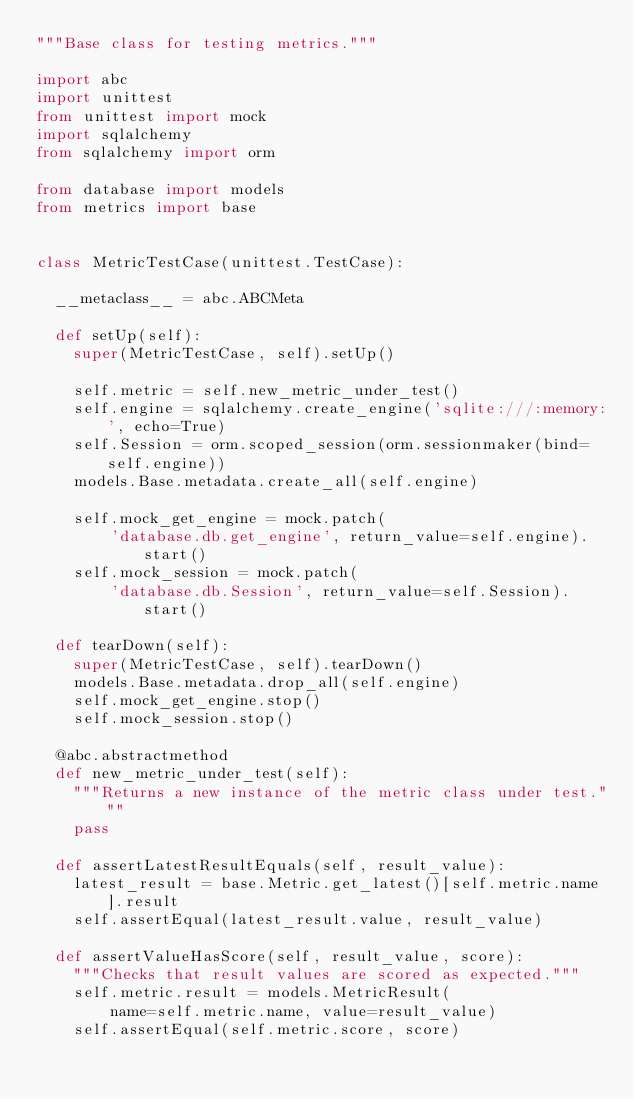Convert code to text. <code><loc_0><loc_0><loc_500><loc_500><_Python_>"""Base class for testing metrics."""

import abc
import unittest
from unittest import mock
import sqlalchemy
from sqlalchemy import orm

from database import models
from metrics import base


class MetricTestCase(unittest.TestCase):

  __metaclass__ = abc.ABCMeta

  def setUp(self):
    super(MetricTestCase, self).setUp()

    self.metric = self.new_metric_under_test()
    self.engine = sqlalchemy.create_engine('sqlite:///:memory:', echo=True)
    self.Session = orm.scoped_session(orm.sessionmaker(bind=self.engine))
    models.Base.metadata.create_all(self.engine)

    self.mock_get_engine = mock.patch(
        'database.db.get_engine', return_value=self.engine).start()
    self.mock_session = mock.patch(
        'database.db.Session', return_value=self.Session).start()

  def tearDown(self):
    super(MetricTestCase, self).tearDown()
    models.Base.metadata.drop_all(self.engine)
    self.mock_get_engine.stop()
    self.mock_session.stop()

  @abc.abstractmethod
  def new_metric_under_test(self):
    """Returns a new instance of the metric class under test."""
    pass

  def assertLatestResultEquals(self, result_value):
    latest_result = base.Metric.get_latest()[self.metric.name].result
    self.assertEqual(latest_result.value, result_value)

  def assertValueHasScore(self, result_value, score):
    """Checks that result values are scored as expected."""
    self.metric.result = models.MetricResult(
        name=self.metric.name, value=result_value)
    self.assertEqual(self.metric.score, score)
</code> 